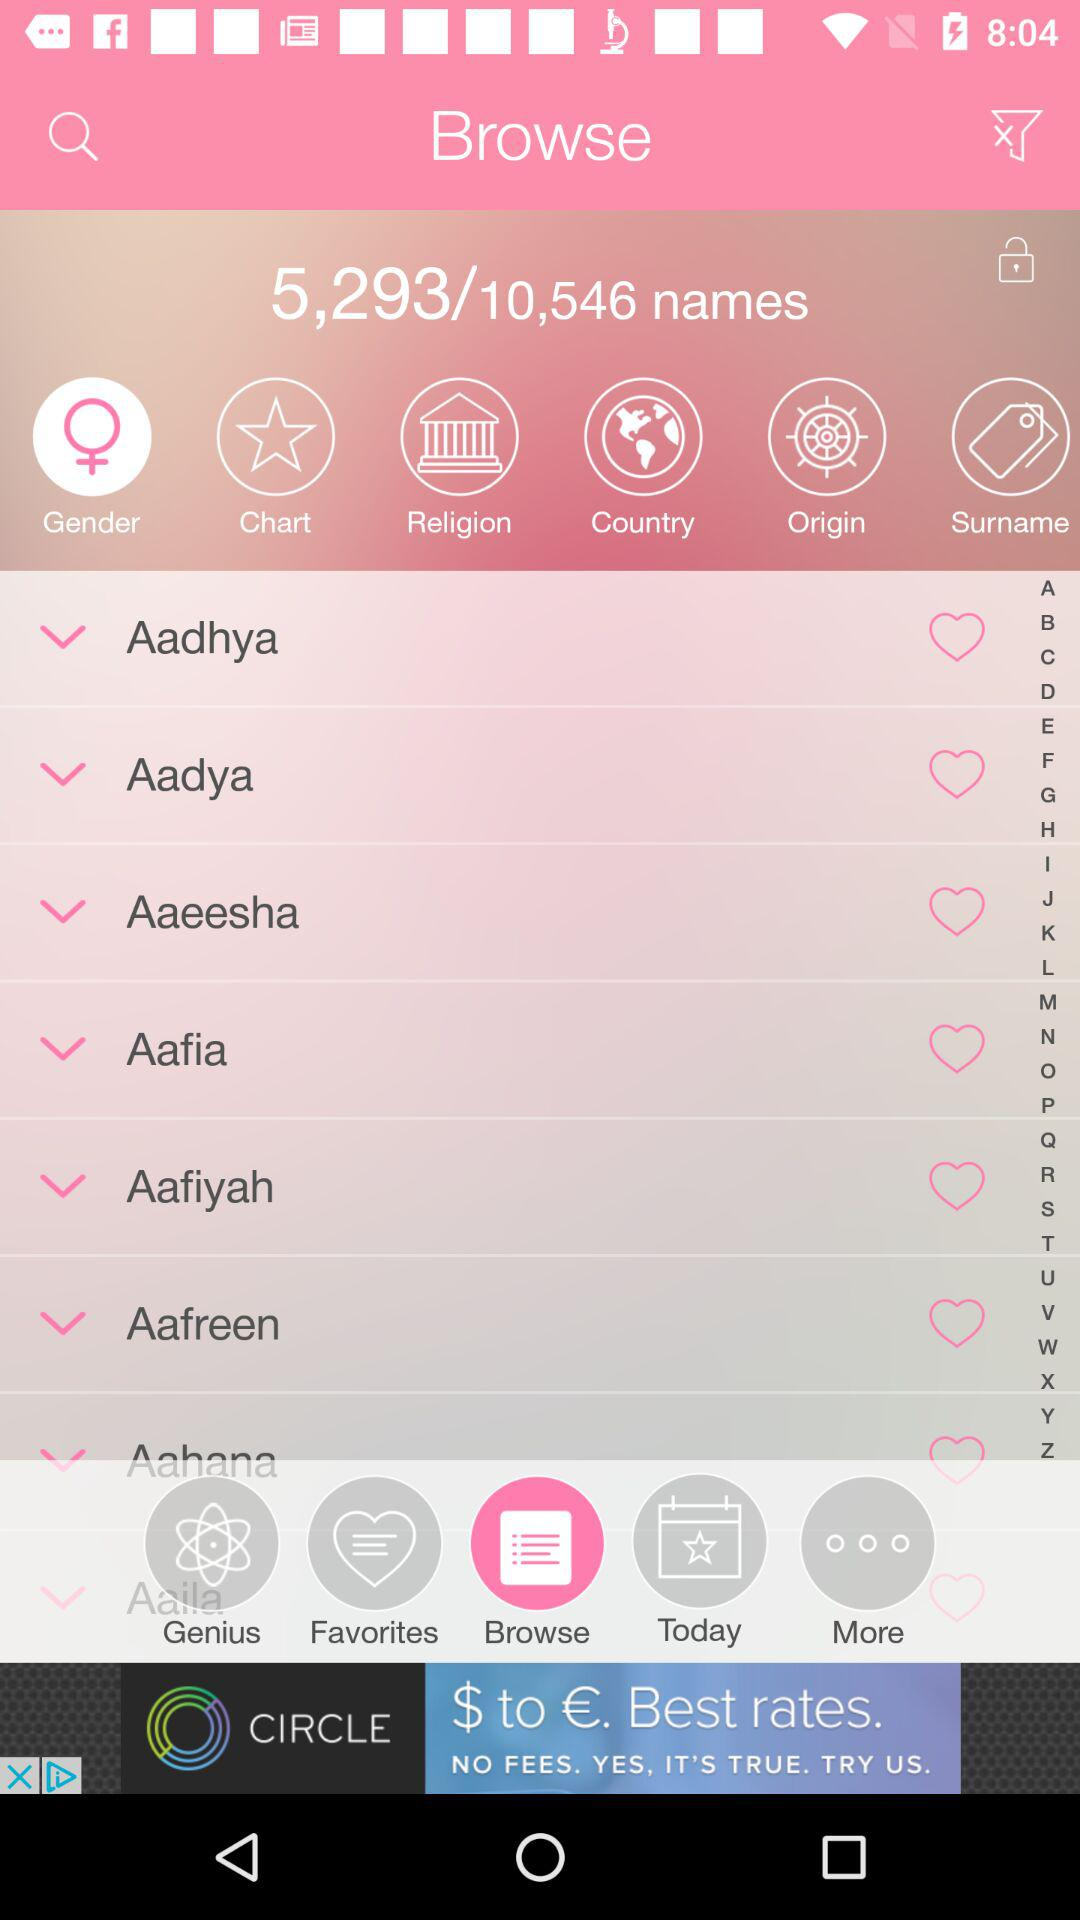Which tab has been selected? The tabs "Browse" and "Gender" have been selected. 